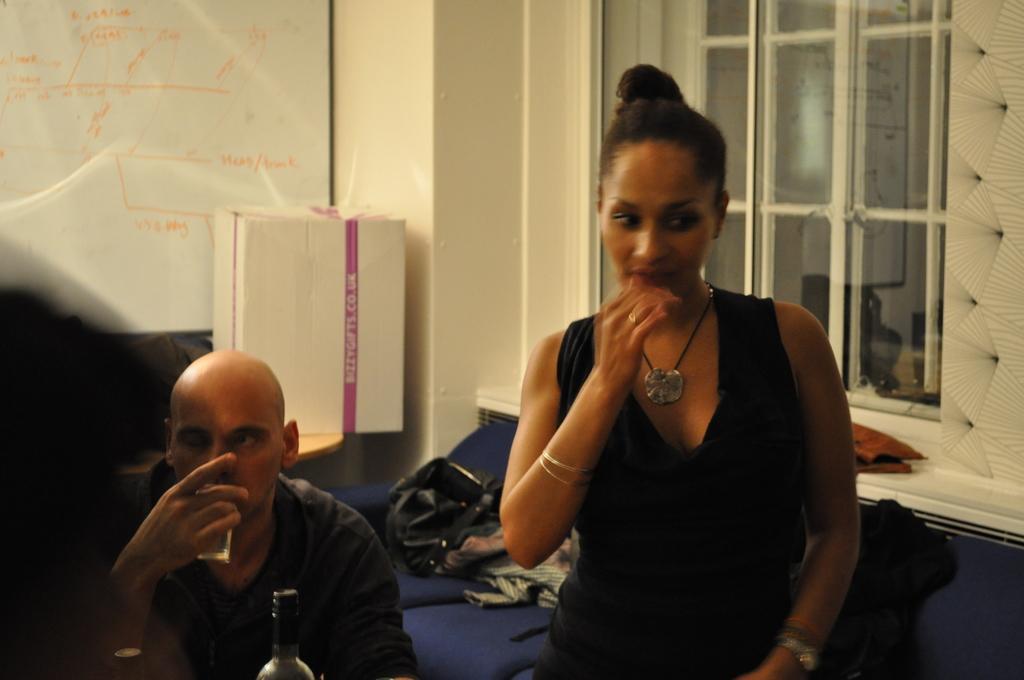Please provide a concise description of this image. This is an inside view. On the right side, I can see a woman wearing black color dress and standing. On the left side there is a man holding a glass in hand and drinking something. In the background there is a table on which few clothes are placed. On the top of the image I can see a wall, window and on the left side I can see a sheet is attached to the wall. In front of it I can see a white color box. 